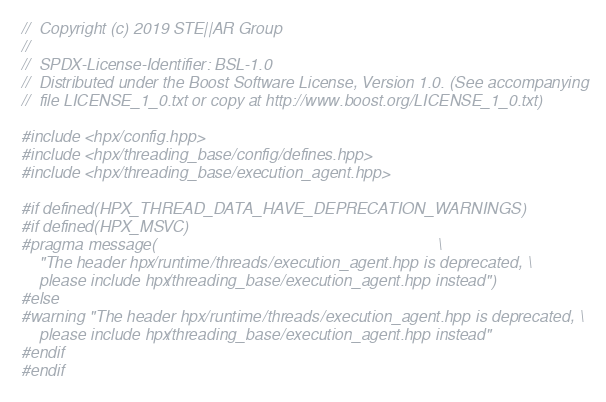Convert code to text. <code><loc_0><loc_0><loc_500><loc_500><_C++_>//  Copyright (c) 2019 STE||AR Group
//
//  SPDX-License-Identifier: BSL-1.0
//  Distributed under the Boost Software License, Version 1.0. (See accompanying
//  file LICENSE_1_0.txt or copy at http://www.boost.org/LICENSE_1_0.txt)

#include <hpx/config.hpp>
#include <hpx/threading_base/config/defines.hpp>
#include <hpx/threading_base/execution_agent.hpp>

#if defined(HPX_THREAD_DATA_HAVE_DEPRECATION_WARNINGS)
#if defined(HPX_MSVC)
#pragma message(                                                               \
    "The header hpx/runtime/threads/execution_agent.hpp is deprecated, \
    please include hpx/threading_base/execution_agent.hpp instead")
#else
#warning "The header hpx/runtime/threads/execution_agent.hpp is deprecated, \
    please include hpx/threading_base/execution_agent.hpp instead"
#endif
#endif
</code> 